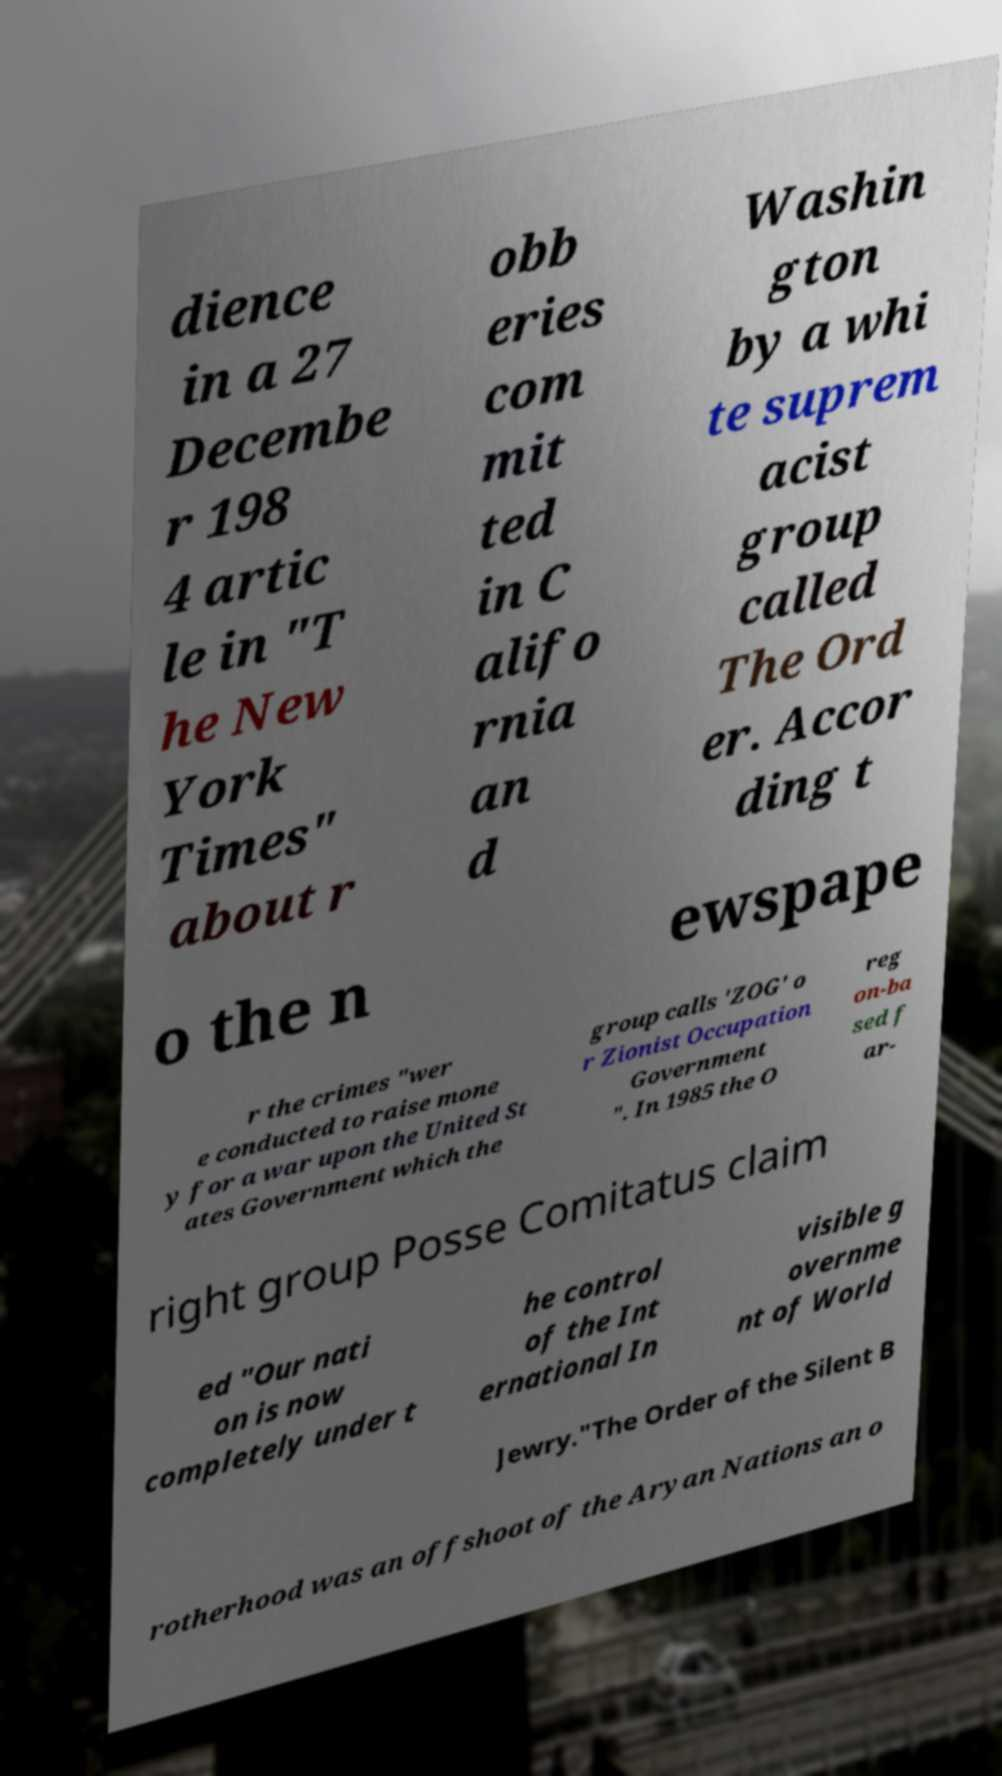Can you read and provide the text displayed in the image?This photo seems to have some interesting text. Can you extract and type it out for me? dience in a 27 Decembe r 198 4 artic le in "T he New York Times" about r obb eries com mit ted in C alifo rnia an d Washin gton by a whi te suprem acist group called The Ord er. Accor ding t o the n ewspape r the crimes "wer e conducted to raise mone y for a war upon the United St ates Government which the group calls 'ZOG' o r Zionist Occupation Government ". In 1985 the O reg on-ba sed f ar- right group Posse Comitatus claim ed "Our nati on is now completely under t he control of the Int ernational In visible g overnme nt of World Jewry."The Order of the Silent B rotherhood was an offshoot of the Aryan Nations an o 